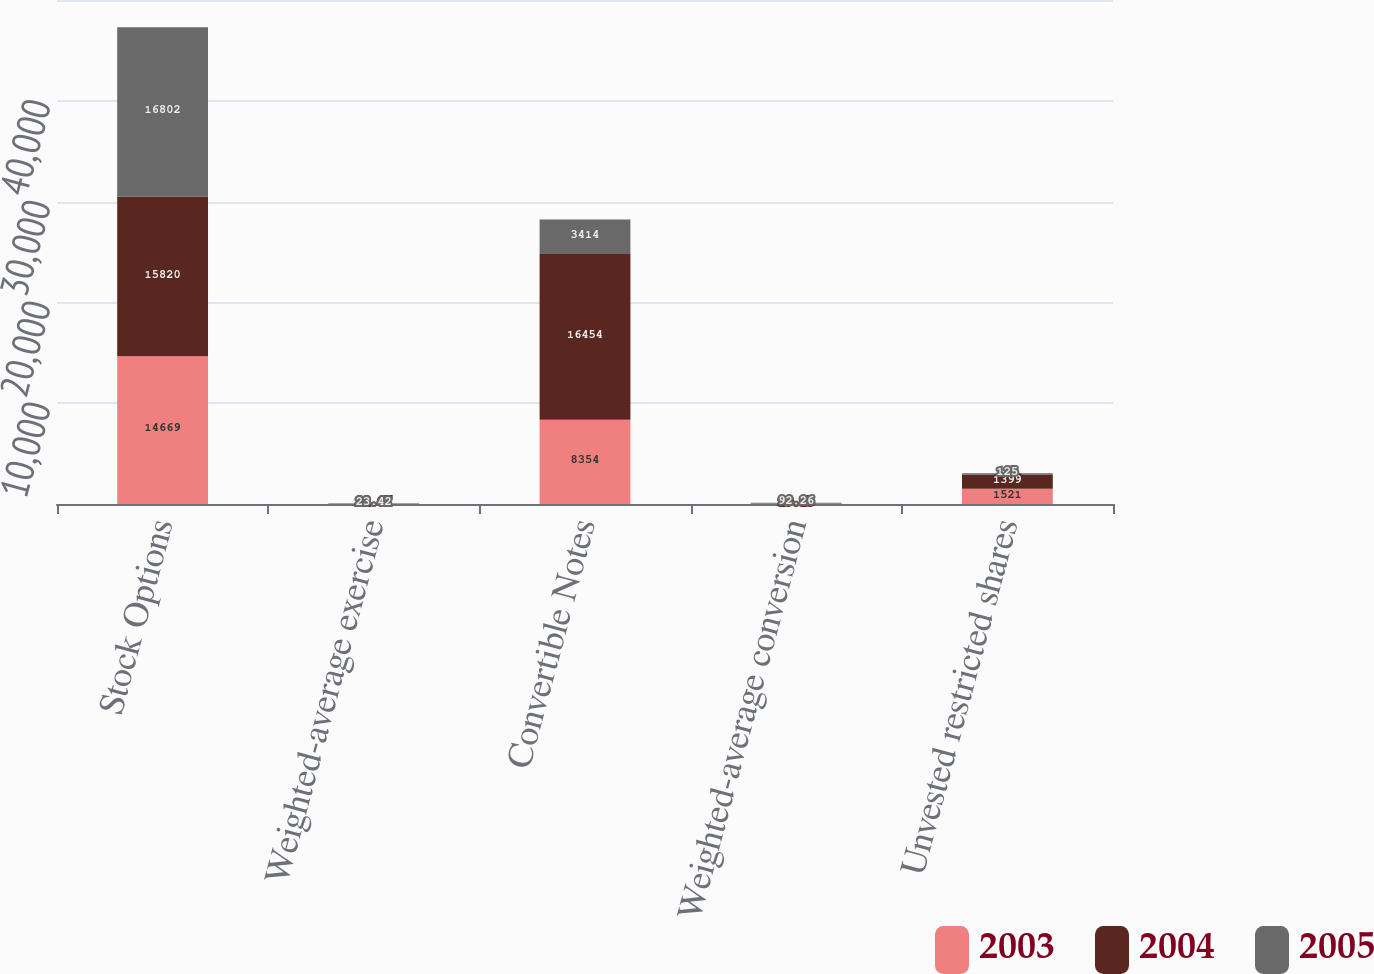<chart> <loc_0><loc_0><loc_500><loc_500><stacked_bar_chart><ecel><fcel>Stock Options<fcel>Weighted-average exercise<fcel>Convertible Notes<fcel>Weighted-average conversion<fcel>Unvested restricted shares<nl><fcel>2003<fcel>14669<fcel>22.84<fcel>8354<fcel>19.16<fcel>1521<nl><fcel>2004<fcel>15820<fcel>22.67<fcel>16454<fcel>19.15<fcel>1399<nl><fcel>2005<fcel>16802<fcel>23.42<fcel>3414<fcel>92.26<fcel>125<nl></chart> 